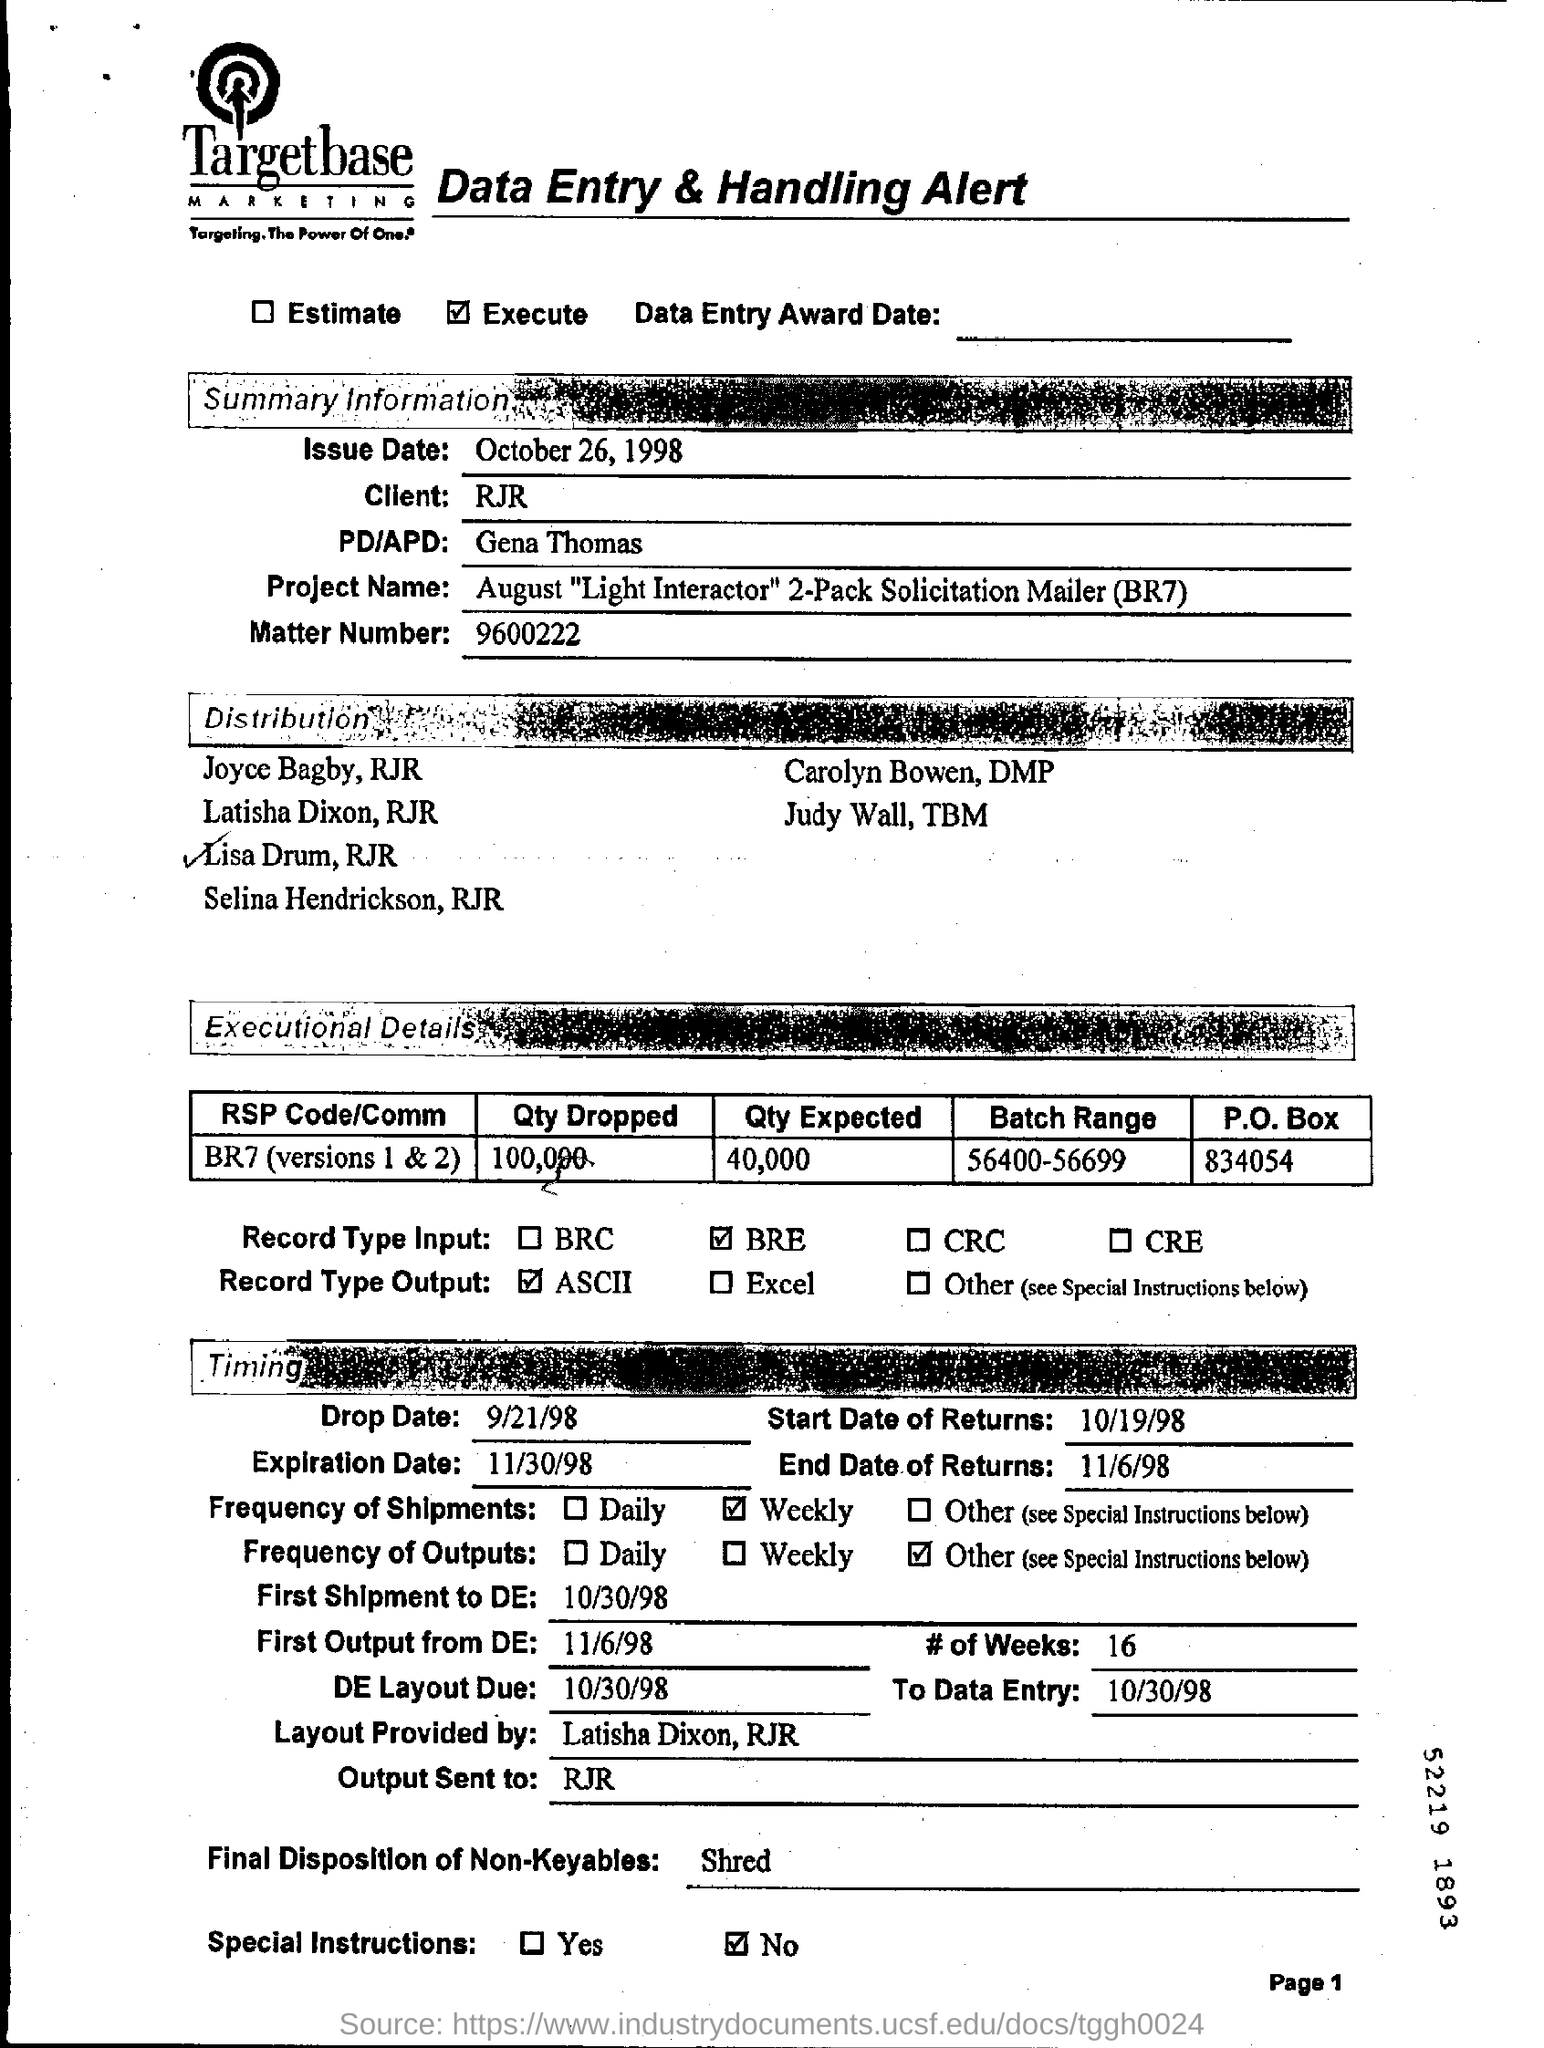Outline some significant characteristics in this image. The drop date is September 21, 1998. The name is "Gena Thomas. The expiration date is November 30th, 1998. The output is sent to the recipient named in the address. The matter number is 9600222...," the speaker stated. 